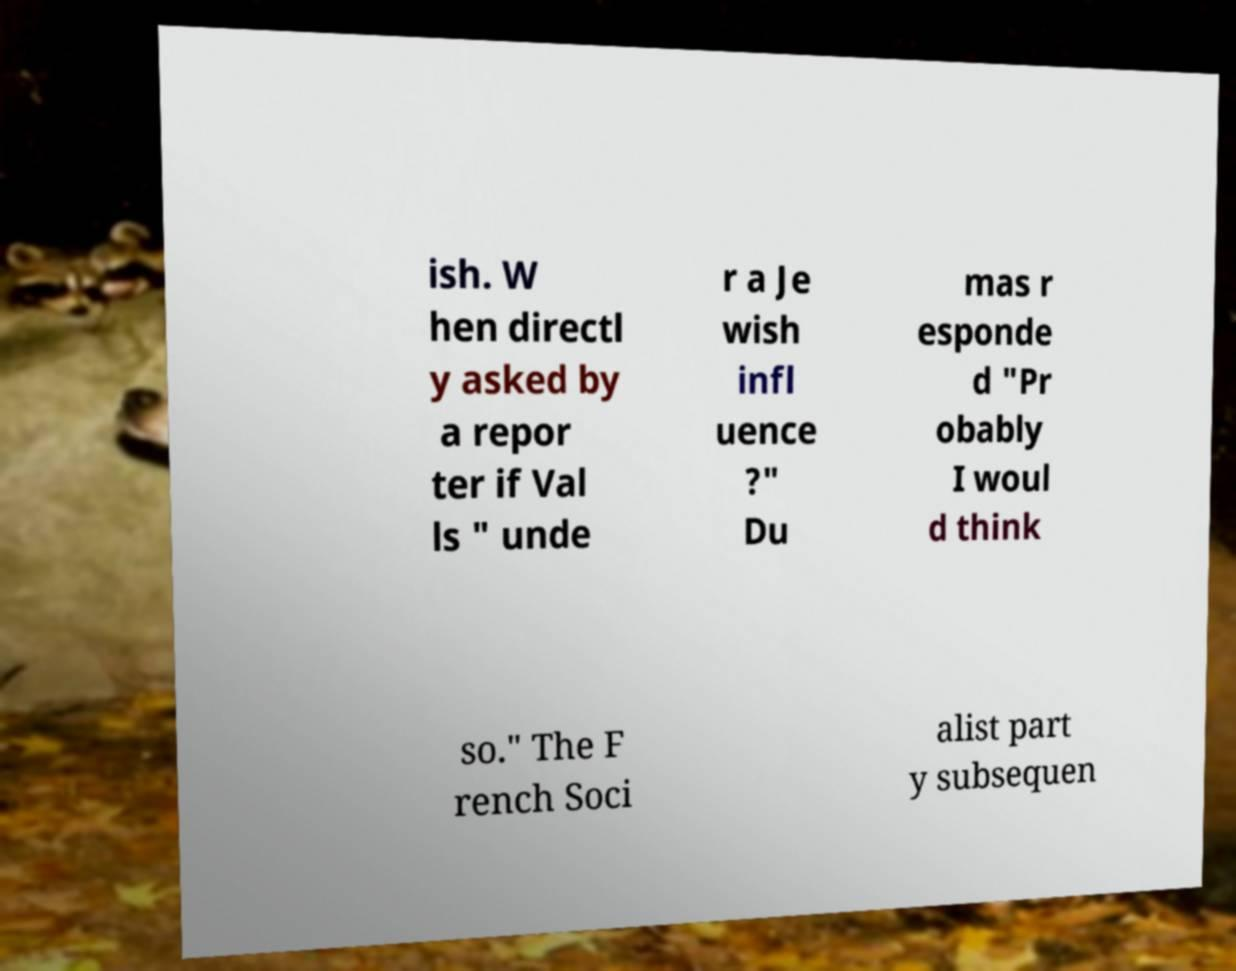Please identify and transcribe the text found in this image. ish. W hen directl y asked by a repor ter if Val ls " unde r a Je wish infl uence ?" Du mas r esponde d "Pr obably I woul d think so." The F rench Soci alist part y subsequen 